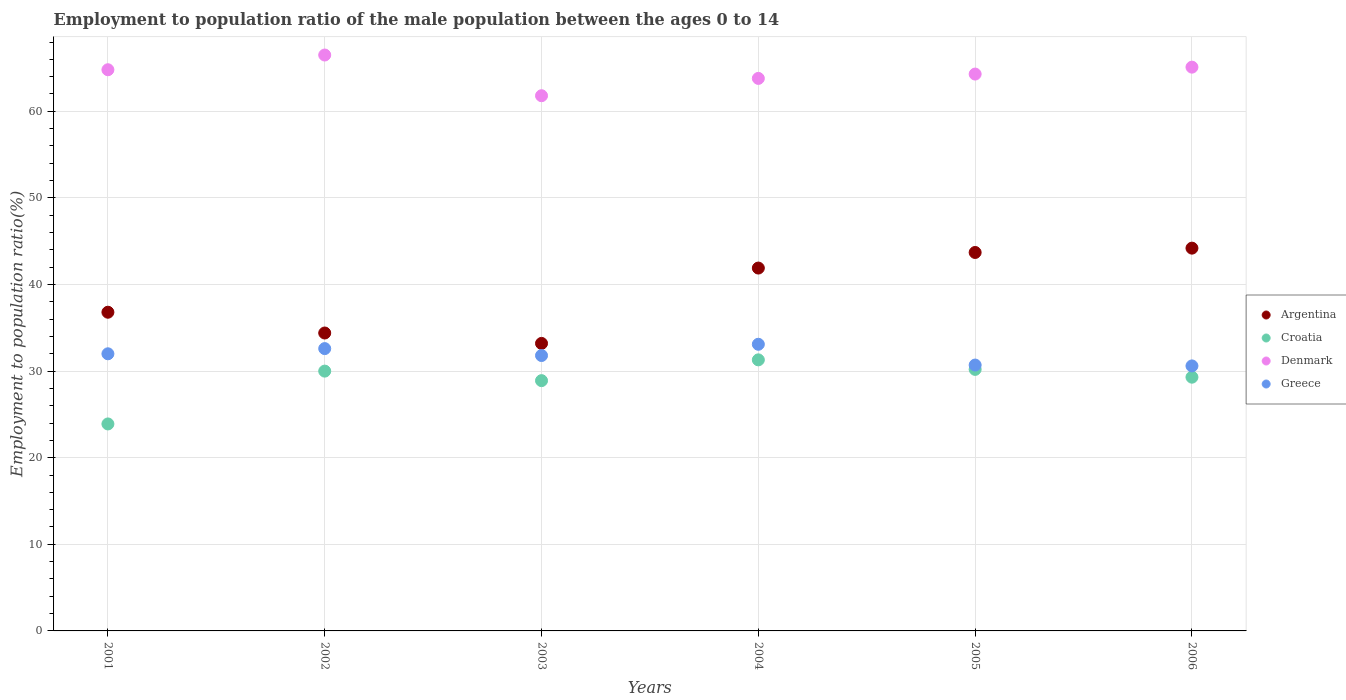What is the employment to population ratio in Greece in 2002?
Make the answer very short. 32.6. Across all years, what is the maximum employment to population ratio in Denmark?
Make the answer very short. 66.5. Across all years, what is the minimum employment to population ratio in Croatia?
Offer a terse response. 23.9. What is the total employment to population ratio in Croatia in the graph?
Offer a very short reply. 173.6. What is the difference between the employment to population ratio in Croatia in 2006 and the employment to population ratio in Denmark in 2005?
Provide a succinct answer. -35. What is the average employment to population ratio in Croatia per year?
Your response must be concise. 28.93. In the year 2003, what is the difference between the employment to population ratio in Greece and employment to population ratio in Argentina?
Your answer should be very brief. -1.4. What is the ratio of the employment to population ratio in Denmark in 2004 to that in 2005?
Your answer should be very brief. 0.99. Is the difference between the employment to population ratio in Greece in 2001 and 2006 greater than the difference between the employment to population ratio in Argentina in 2001 and 2006?
Your answer should be compact. Yes. What is the difference between the highest and the second highest employment to population ratio in Croatia?
Your answer should be very brief. 1.1. In how many years, is the employment to population ratio in Argentina greater than the average employment to population ratio in Argentina taken over all years?
Your answer should be very brief. 3. Is the sum of the employment to population ratio in Argentina in 2001 and 2006 greater than the maximum employment to population ratio in Croatia across all years?
Ensure brevity in your answer.  Yes. Is it the case that in every year, the sum of the employment to population ratio in Argentina and employment to population ratio in Greece  is greater than the sum of employment to population ratio in Croatia and employment to population ratio in Denmark?
Ensure brevity in your answer.  No. Is the employment to population ratio in Croatia strictly less than the employment to population ratio in Denmark over the years?
Provide a succinct answer. Yes. How many years are there in the graph?
Your answer should be compact. 6. Does the graph contain grids?
Your answer should be compact. Yes. Where does the legend appear in the graph?
Provide a short and direct response. Center right. What is the title of the graph?
Offer a terse response. Employment to population ratio of the male population between the ages 0 to 14. What is the Employment to population ratio(%) in Argentina in 2001?
Your answer should be very brief. 36.8. What is the Employment to population ratio(%) in Croatia in 2001?
Your answer should be compact. 23.9. What is the Employment to population ratio(%) in Denmark in 2001?
Your response must be concise. 64.8. What is the Employment to population ratio(%) of Greece in 2001?
Your answer should be compact. 32. What is the Employment to population ratio(%) in Argentina in 2002?
Offer a terse response. 34.4. What is the Employment to population ratio(%) in Denmark in 2002?
Ensure brevity in your answer.  66.5. What is the Employment to population ratio(%) in Greece in 2002?
Give a very brief answer. 32.6. What is the Employment to population ratio(%) in Argentina in 2003?
Provide a short and direct response. 33.2. What is the Employment to population ratio(%) in Croatia in 2003?
Your answer should be very brief. 28.9. What is the Employment to population ratio(%) in Denmark in 2003?
Provide a succinct answer. 61.8. What is the Employment to population ratio(%) of Greece in 2003?
Make the answer very short. 31.8. What is the Employment to population ratio(%) of Argentina in 2004?
Your answer should be compact. 41.9. What is the Employment to population ratio(%) in Croatia in 2004?
Your answer should be compact. 31.3. What is the Employment to population ratio(%) in Denmark in 2004?
Provide a succinct answer. 63.8. What is the Employment to population ratio(%) in Greece in 2004?
Your response must be concise. 33.1. What is the Employment to population ratio(%) in Argentina in 2005?
Keep it short and to the point. 43.7. What is the Employment to population ratio(%) in Croatia in 2005?
Provide a short and direct response. 30.2. What is the Employment to population ratio(%) of Denmark in 2005?
Ensure brevity in your answer.  64.3. What is the Employment to population ratio(%) in Greece in 2005?
Make the answer very short. 30.7. What is the Employment to population ratio(%) of Argentina in 2006?
Offer a terse response. 44.2. What is the Employment to population ratio(%) in Croatia in 2006?
Your answer should be compact. 29.3. What is the Employment to population ratio(%) of Denmark in 2006?
Offer a terse response. 65.1. What is the Employment to population ratio(%) in Greece in 2006?
Your answer should be compact. 30.6. Across all years, what is the maximum Employment to population ratio(%) in Argentina?
Your answer should be very brief. 44.2. Across all years, what is the maximum Employment to population ratio(%) in Croatia?
Provide a succinct answer. 31.3. Across all years, what is the maximum Employment to population ratio(%) in Denmark?
Offer a very short reply. 66.5. Across all years, what is the maximum Employment to population ratio(%) in Greece?
Keep it short and to the point. 33.1. Across all years, what is the minimum Employment to population ratio(%) in Argentina?
Provide a short and direct response. 33.2. Across all years, what is the minimum Employment to population ratio(%) of Croatia?
Give a very brief answer. 23.9. Across all years, what is the minimum Employment to population ratio(%) in Denmark?
Offer a very short reply. 61.8. Across all years, what is the minimum Employment to population ratio(%) in Greece?
Provide a succinct answer. 30.6. What is the total Employment to population ratio(%) of Argentina in the graph?
Ensure brevity in your answer.  234.2. What is the total Employment to population ratio(%) in Croatia in the graph?
Provide a succinct answer. 173.6. What is the total Employment to population ratio(%) of Denmark in the graph?
Your response must be concise. 386.3. What is the total Employment to population ratio(%) of Greece in the graph?
Your answer should be very brief. 190.8. What is the difference between the Employment to population ratio(%) in Croatia in 2001 and that in 2002?
Give a very brief answer. -6.1. What is the difference between the Employment to population ratio(%) of Denmark in 2001 and that in 2002?
Ensure brevity in your answer.  -1.7. What is the difference between the Employment to population ratio(%) of Greece in 2001 and that in 2002?
Your response must be concise. -0.6. What is the difference between the Employment to population ratio(%) of Argentina in 2001 and that in 2003?
Ensure brevity in your answer.  3.6. What is the difference between the Employment to population ratio(%) of Croatia in 2001 and that in 2003?
Ensure brevity in your answer.  -5. What is the difference between the Employment to population ratio(%) of Denmark in 2001 and that in 2003?
Your answer should be compact. 3. What is the difference between the Employment to population ratio(%) of Greece in 2001 and that in 2003?
Your answer should be compact. 0.2. What is the difference between the Employment to population ratio(%) in Argentina in 2001 and that in 2004?
Ensure brevity in your answer.  -5.1. What is the difference between the Employment to population ratio(%) in Croatia in 2001 and that in 2004?
Keep it short and to the point. -7.4. What is the difference between the Employment to population ratio(%) of Greece in 2001 and that in 2004?
Your response must be concise. -1.1. What is the difference between the Employment to population ratio(%) of Argentina in 2001 and that in 2005?
Provide a succinct answer. -6.9. What is the difference between the Employment to population ratio(%) of Greece in 2001 and that in 2005?
Make the answer very short. 1.3. What is the difference between the Employment to population ratio(%) of Denmark in 2001 and that in 2006?
Offer a very short reply. -0.3. What is the difference between the Employment to population ratio(%) in Greece in 2001 and that in 2006?
Provide a short and direct response. 1.4. What is the difference between the Employment to population ratio(%) of Croatia in 2002 and that in 2003?
Offer a very short reply. 1.1. What is the difference between the Employment to population ratio(%) in Greece in 2002 and that in 2003?
Provide a short and direct response. 0.8. What is the difference between the Employment to population ratio(%) of Greece in 2002 and that in 2004?
Make the answer very short. -0.5. What is the difference between the Employment to population ratio(%) of Denmark in 2002 and that in 2005?
Your answer should be very brief. 2.2. What is the difference between the Employment to population ratio(%) in Greece in 2002 and that in 2005?
Offer a very short reply. 1.9. What is the difference between the Employment to population ratio(%) of Croatia in 2002 and that in 2006?
Your answer should be compact. 0.7. What is the difference between the Employment to population ratio(%) of Croatia in 2003 and that in 2004?
Keep it short and to the point. -2.4. What is the difference between the Employment to population ratio(%) in Denmark in 2003 and that in 2004?
Offer a very short reply. -2. What is the difference between the Employment to population ratio(%) in Greece in 2003 and that in 2004?
Your answer should be compact. -1.3. What is the difference between the Employment to population ratio(%) of Argentina in 2003 and that in 2005?
Keep it short and to the point. -10.5. What is the difference between the Employment to population ratio(%) of Argentina in 2003 and that in 2006?
Keep it short and to the point. -11. What is the difference between the Employment to population ratio(%) of Croatia in 2003 and that in 2006?
Offer a very short reply. -0.4. What is the difference between the Employment to population ratio(%) in Denmark in 2003 and that in 2006?
Make the answer very short. -3.3. What is the difference between the Employment to population ratio(%) of Greece in 2003 and that in 2006?
Your answer should be compact. 1.2. What is the difference between the Employment to population ratio(%) in Argentina in 2004 and that in 2005?
Provide a short and direct response. -1.8. What is the difference between the Employment to population ratio(%) in Croatia in 2004 and that in 2005?
Offer a terse response. 1.1. What is the difference between the Employment to population ratio(%) in Greece in 2004 and that in 2005?
Keep it short and to the point. 2.4. What is the difference between the Employment to population ratio(%) in Croatia in 2004 and that in 2006?
Give a very brief answer. 2. What is the difference between the Employment to population ratio(%) in Denmark in 2004 and that in 2006?
Your answer should be very brief. -1.3. What is the difference between the Employment to population ratio(%) of Argentina in 2005 and that in 2006?
Provide a short and direct response. -0.5. What is the difference between the Employment to population ratio(%) of Argentina in 2001 and the Employment to population ratio(%) of Croatia in 2002?
Provide a succinct answer. 6.8. What is the difference between the Employment to population ratio(%) in Argentina in 2001 and the Employment to population ratio(%) in Denmark in 2002?
Your answer should be compact. -29.7. What is the difference between the Employment to population ratio(%) of Argentina in 2001 and the Employment to population ratio(%) of Greece in 2002?
Make the answer very short. 4.2. What is the difference between the Employment to population ratio(%) of Croatia in 2001 and the Employment to population ratio(%) of Denmark in 2002?
Your answer should be very brief. -42.6. What is the difference between the Employment to population ratio(%) in Croatia in 2001 and the Employment to population ratio(%) in Greece in 2002?
Keep it short and to the point. -8.7. What is the difference between the Employment to population ratio(%) of Denmark in 2001 and the Employment to population ratio(%) of Greece in 2002?
Give a very brief answer. 32.2. What is the difference between the Employment to population ratio(%) of Argentina in 2001 and the Employment to population ratio(%) of Croatia in 2003?
Offer a very short reply. 7.9. What is the difference between the Employment to population ratio(%) of Argentina in 2001 and the Employment to population ratio(%) of Denmark in 2003?
Your answer should be compact. -25. What is the difference between the Employment to population ratio(%) of Croatia in 2001 and the Employment to population ratio(%) of Denmark in 2003?
Offer a very short reply. -37.9. What is the difference between the Employment to population ratio(%) in Argentina in 2001 and the Employment to population ratio(%) in Greece in 2004?
Keep it short and to the point. 3.7. What is the difference between the Employment to population ratio(%) of Croatia in 2001 and the Employment to population ratio(%) of Denmark in 2004?
Provide a short and direct response. -39.9. What is the difference between the Employment to population ratio(%) of Denmark in 2001 and the Employment to population ratio(%) of Greece in 2004?
Your answer should be compact. 31.7. What is the difference between the Employment to population ratio(%) of Argentina in 2001 and the Employment to population ratio(%) of Croatia in 2005?
Provide a succinct answer. 6.6. What is the difference between the Employment to population ratio(%) of Argentina in 2001 and the Employment to population ratio(%) of Denmark in 2005?
Your answer should be very brief. -27.5. What is the difference between the Employment to population ratio(%) of Argentina in 2001 and the Employment to population ratio(%) of Greece in 2005?
Ensure brevity in your answer.  6.1. What is the difference between the Employment to population ratio(%) in Croatia in 2001 and the Employment to population ratio(%) in Denmark in 2005?
Make the answer very short. -40.4. What is the difference between the Employment to population ratio(%) of Croatia in 2001 and the Employment to population ratio(%) of Greece in 2005?
Make the answer very short. -6.8. What is the difference between the Employment to population ratio(%) in Denmark in 2001 and the Employment to population ratio(%) in Greece in 2005?
Offer a terse response. 34.1. What is the difference between the Employment to population ratio(%) of Argentina in 2001 and the Employment to population ratio(%) of Denmark in 2006?
Provide a short and direct response. -28.3. What is the difference between the Employment to population ratio(%) of Argentina in 2001 and the Employment to population ratio(%) of Greece in 2006?
Provide a short and direct response. 6.2. What is the difference between the Employment to population ratio(%) in Croatia in 2001 and the Employment to population ratio(%) in Denmark in 2006?
Your answer should be compact. -41.2. What is the difference between the Employment to population ratio(%) of Denmark in 2001 and the Employment to population ratio(%) of Greece in 2006?
Give a very brief answer. 34.2. What is the difference between the Employment to population ratio(%) in Argentina in 2002 and the Employment to population ratio(%) in Croatia in 2003?
Your response must be concise. 5.5. What is the difference between the Employment to population ratio(%) of Argentina in 2002 and the Employment to population ratio(%) of Denmark in 2003?
Offer a very short reply. -27.4. What is the difference between the Employment to population ratio(%) in Croatia in 2002 and the Employment to population ratio(%) in Denmark in 2003?
Make the answer very short. -31.8. What is the difference between the Employment to population ratio(%) of Croatia in 2002 and the Employment to population ratio(%) of Greece in 2003?
Your response must be concise. -1.8. What is the difference between the Employment to population ratio(%) of Denmark in 2002 and the Employment to population ratio(%) of Greece in 2003?
Keep it short and to the point. 34.7. What is the difference between the Employment to population ratio(%) in Argentina in 2002 and the Employment to population ratio(%) in Croatia in 2004?
Ensure brevity in your answer.  3.1. What is the difference between the Employment to population ratio(%) of Argentina in 2002 and the Employment to population ratio(%) of Denmark in 2004?
Offer a terse response. -29.4. What is the difference between the Employment to population ratio(%) of Argentina in 2002 and the Employment to population ratio(%) of Greece in 2004?
Ensure brevity in your answer.  1.3. What is the difference between the Employment to population ratio(%) in Croatia in 2002 and the Employment to population ratio(%) in Denmark in 2004?
Give a very brief answer. -33.8. What is the difference between the Employment to population ratio(%) in Denmark in 2002 and the Employment to population ratio(%) in Greece in 2004?
Offer a very short reply. 33.4. What is the difference between the Employment to population ratio(%) in Argentina in 2002 and the Employment to population ratio(%) in Croatia in 2005?
Ensure brevity in your answer.  4.2. What is the difference between the Employment to population ratio(%) of Argentina in 2002 and the Employment to population ratio(%) of Denmark in 2005?
Offer a very short reply. -29.9. What is the difference between the Employment to population ratio(%) of Croatia in 2002 and the Employment to population ratio(%) of Denmark in 2005?
Provide a succinct answer. -34.3. What is the difference between the Employment to population ratio(%) of Denmark in 2002 and the Employment to population ratio(%) of Greece in 2005?
Ensure brevity in your answer.  35.8. What is the difference between the Employment to population ratio(%) of Argentina in 2002 and the Employment to population ratio(%) of Denmark in 2006?
Your answer should be compact. -30.7. What is the difference between the Employment to population ratio(%) in Croatia in 2002 and the Employment to population ratio(%) in Denmark in 2006?
Offer a terse response. -35.1. What is the difference between the Employment to population ratio(%) of Croatia in 2002 and the Employment to population ratio(%) of Greece in 2006?
Provide a short and direct response. -0.6. What is the difference between the Employment to population ratio(%) in Denmark in 2002 and the Employment to population ratio(%) in Greece in 2006?
Ensure brevity in your answer.  35.9. What is the difference between the Employment to population ratio(%) in Argentina in 2003 and the Employment to population ratio(%) in Denmark in 2004?
Give a very brief answer. -30.6. What is the difference between the Employment to population ratio(%) of Croatia in 2003 and the Employment to population ratio(%) of Denmark in 2004?
Your response must be concise. -34.9. What is the difference between the Employment to population ratio(%) in Croatia in 2003 and the Employment to population ratio(%) in Greece in 2004?
Keep it short and to the point. -4.2. What is the difference between the Employment to population ratio(%) of Denmark in 2003 and the Employment to population ratio(%) of Greece in 2004?
Ensure brevity in your answer.  28.7. What is the difference between the Employment to population ratio(%) of Argentina in 2003 and the Employment to population ratio(%) of Denmark in 2005?
Keep it short and to the point. -31.1. What is the difference between the Employment to population ratio(%) of Argentina in 2003 and the Employment to population ratio(%) of Greece in 2005?
Make the answer very short. 2.5. What is the difference between the Employment to population ratio(%) of Croatia in 2003 and the Employment to population ratio(%) of Denmark in 2005?
Offer a very short reply. -35.4. What is the difference between the Employment to population ratio(%) in Croatia in 2003 and the Employment to population ratio(%) in Greece in 2005?
Your answer should be very brief. -1.8. What is the difference between the Employment to population ratio(%) of Denmark in 2003 and the Employment to population ratio(%) of Greece in 2005?
Your response must be concise. 31.1. What is the difference between the Employment to population ratio(%) in Argentina in 2003 and the Employment to population ratio(%) in Denmark in 2006?
Offer a terse response. -31.9. What is the difference between the Employment to population ratio(%) of Argentina in 2003 and the Employment to population ratio(%) of Greece in 2006?
Provide a succinct answer. 2.6. What is the difference between the Employment to population ratio(%) of Croatia in 2003 and the Employment to population ratio(%) of Denmark in 2006?
Ensure brevity in your answer.  -36.2. What is the difference between the Employment to population ratio(%) in Denmark in 2003 and the Employment to population ratio(%) in Greece in 2006?
Your answer should be compact. 31.2. What is the difference between the Employment to population ratio(%) of Argentina in 2004 and the Employment to population ratio(%) of Croatia in 2005?
Make the answer very short. 11.7. What is the difference between the Employment to population ratio(%) in Argentina in 2004 and the Employment to population ratio(%) in Denmark in 2005?
Your response must be concise. -22.4. What is the difference between the Employment to population ratio(%) in Croatia in 2004 and the Employment to population ratio(%) in Denmark in 2005?
Give a very brief answer. -33. What is the difference between the Employment to population ratio(%) of Denmark in 2004 and the Employment to population ratio(%) of Greece in 2005?
Your answer should be compact. 33.1. What is the difference between the Employment to population ratio(%) of Argentina in 2004 and the Employment to population ratio(%) of Denmark in 2006?
Offer a terse response. -23.2. What is the difference between the Employment to population ratio(%) in Croatia in 2004 and the Employment to population ratio(%) in Denmark in 2006?
Give a very brief answer. -33.8. What is the difference between the Employment to population ratio(%) in Denmark in 2004 and the Employment to population ratio(%) in Greece in 2006?
Offer a terse response. 33.2. What is the difference between the Employment to population ratio(%) of Argentina in 2005 and the Employment to population ratio(%) of Denmark in 2006?
Keep it short and to the point. -21.4. What is the difference between the Employment to population ratio(%) of Croatia in 2005 and the Employment to population ratio(%) of Denmark in 2006?
Provide a short and direct response. -34.9. What is the difference between the Employment to population ratio(%) in Denmark in 2005 and the Employment to population ratio(%) in Greece in 2006?
Keep it short and to the point. 33.7. What is the average Employment to population ratio(%) of Argentina per year?
Your answer should be very brief. 39.03. What is the average Employment to population ratio(%) of Croatia per year?
Keep it short and to the point. 28.93. What is the average Employment to population ratio(%) in Denmark per year?
Your answer should be compact. 64.38. What is the average Employment to population ratio(%) in Greece per year?
Make the answer very short. 31.8. In the year 2001, what is the difference between the Employment to population ratio(%) of Argentina and Employment to population ratio(%) of Denmark?
Keep it short and to the point. -28. In the year 2001, what is the difference between the Employment to population ratio(%) in Argentina and Employment to population ratio(%) in Greece?
Offer a terse response. 4.8. In the year 2001, what is the difference between the Employment to population ratio(%) of Croatia and Employment to population ratio(%) of Denmark?
Offer a very short reply. -40.9. In the year 2001, what is the difference between the Employment to population ratio(%) of Denmark and Employment to population ratio(%) of Greece?
Offer a terse response. 32.8. In the year 2002, what is the difference between the Employment to population ratio(%) in Argentina and Employment to population ratio(%) in Croatia?
Offer a very short reply. 4.4. In the year 2002, what is the difference between the Employment to population ratio(%) of Argentina and Employment to population ratio(%) of Denmark?
Give a very brief answer. -32.1. In the year 2002, what is the difference between the Employment to population ratio(%) of Argentina and Employment to population ratio(%) of Greece?
Give a very brief answer. 1.8. In the year 2002, what is the difference between the Employment to population ratio(%) of Croatia and Employment to population ratio(%) of Denmark?
Ensure brevity in your answer.  -36.5. In the year 2002, what is the difference between the Employment to population ratio(%) of Denmark and Employment to population ratio(%) of Greece?
Offer a very short reply. 33.9. In the year 2003, what is the difference between the Employment to population ratio(%) in Argentina and Employment to population ratio(%) in Denmark?
Give a very brief answer. -28.6. In the year 2003, what is the difference between the Employment to population ratio(%) in Argentina and Employment to population ratio(%) in Greece?
Your answer should be compact. 1.4. In the year 2003, what is the difference between the Employment to population ratio(%) in Croatia and Employment to population ratio(%) in Denmark?
Offer a terse response. -32.9. In the year 2003, what is the difference between the Employment to population ratio(%) of Croatia and Employment to population ratio(%) of Greece?
Provide a succinct answer. -2.9. In the year 2004, what is the difference between the Employment to population ratio(%) in Argentina and Employment to population ratio(%) in Denmark?
Provide a short and direct response. -21.9. In the year 2004, what is the difference between the Employment to population ratio(%) of Croatia and Employment to population ratio(%) of Denmark?
Make the answer very short. -32.5. In the year 2004, what is the difference between the Employment to population ratio(%) in Denmark and Employment to population ratio(%) in Greece?
Offer a terse response. 30.7. In the year 2005, what is the difference between the Employment to population ratio(%) in Argentina and Employment to population ratio(%) in Croatia?
Provide a succinct answer. 13.5. In the year 2005, what is the difference between the Employment to population ratio(%) of Argentina and Employment to population ratio(%) of Denmark?
Provide a succinct answer. -20.6. In the year 2005, what is the difference between the Employment to population ratio(%) of Croatia and Employment to population ratio(%) of Denmark?
Offer a very short reply. -34.1. In the year 2005, what is the difference between the Employment to population ratio(%) of Croatia and Employment to population ratio(%) of Greece?
Your answer should be compact. -0.5. In the year 2005, what is the difference between the Employment to population ratio(%) of Denmark and Employment to population ratio(%) of Greece?
Provide a succinct answer. 33.6. In the year 2006, what is the difference between the Employment to population ratio(%) of Argentina and Employment to population ratio(%) of Croatia?
Ensure brevity in your answer.  14.9. In the year 2006, what is the difference between the Employment to population ratio(%) in Argentina and Employment to population ratio(%) in Denmark?
Provide a short and direct response. -20.9. In the year 2006, what is the difference between the Employment to population ratio(%) of Croatia and Employment to population ratio(%) of Denmark?
Give a very brief answer. -35.8. In the year 2006, what is the difference between the Employment to population ratio(%) in Denmark and Employment to population ratio(%) in Greece?
Ensure brevity in your answer.  34.5. What is the ratio of the Employment to population ratio(%) in Argentina in 2001 to that in 2002?
Keep it short and to the point. 1.07. What is the ratio of the Employment to population ratio(%) of Croatia in 2001 to that in 2002?
Provide a succinct answer. 0.8. What is the ratio of the Employment to population ratio(%) in Denmark in 2001 to that in 2002?
Provide a short and direct response. 0.97. What is the ratio of the Employment to population ratio(%) in Greece in 2001 to that in 2002?
Your answer should be very brief. 0.98. What is the ratio of the Employment to population ratio(%) of Argentina in 2001 to that in 2003?
Your answer should be compact. 1.11. What is the ratio of the Employment to population ratio(%) in Croatia in 2001 to that in 2003?
Your answer should be very brief. 0.83. What is the ratio of the Employment to population ratio(%) of Denmark in 2001 to that in 2003?
Give a very brief answer. 1.05. What is the ratio of the Employment to population ratio(%) of Argentina in 2001 to that in 2004?
Provide a succinct answer. 0.88. What is the ratio of the Employment to population ratio(%) of Croatia in 2001 to that in 2004?
Make the answer very short. 0.76. What is the ratio of the Employment to population ratio(%) in Denmark in 2001 to that in 2004?
Provide a short and direct response. 1.02. What is the ratio of the Employment to population ratio(%) of Greece in 2001 to that in 2004?
Your answer should be compact. 0.97. What is the ratio of the Employment to population ratio(%) of Argentina in 2001 to that in 2005?
Give a very brief answer. 0.84. What is the ratio of the Employment to population ratio(%) in Croatia in 2001 to that in 2005?
Keep it short and to the point. 0.79. What is the ratio of the Employment to population ratio(%) in Denmark in 2001 to that in 2005?
Keep it short and to the point. 1.01. What is the ratio of the Employment to population ratio(%) of Greece in 2001 to that in 2005?
Give a very brief answer. 1.04. What is the ratio of the Employment to population ratio(%) of Argentina in 2001 to that in 2006?
Offer a terse response. 0.83. What is the ratio of the Employment to population ratio(%) in Croatia in 2001 to that in 2006?
Keep it short and to the point. 0.82. What is the ratio of the Employment to population ratio(%) of Greece in 2001 to that in 2006?
Make the answer very short. 1.05. What is the ratio of the Employment to population ratio(%) of Argentina in 2002 to that in 2003?
Offer a terse response. 1.04. What is the ratio of the Employment to population ratio(%) of Croatia in 2002 to that in 2003?
Your response must be concise. 1.04. What is the ratio of the Employment to population ratio(%) in Denmark in 2002 to that in 2003?
Give a very brief answer. 1.08. What is the ratio of the Employment to population ratio(%) in Greece in 2002 to that in 2003?
Make the answer very short. 1.03. What is the ratio of the Employment to population ratio(%) in Argentina in 2002 to that in 2004?
Keep it short and to the point. 0.82. What is the ratio of the Employment to population ratio(%) of Croatia in 2002 to that in 2004?
Ensure brevity in your answer.  0.96. What is the ratio of the Employment to population ratio(%) of Denmark in 2002 to that in 2004?
Give a very brief answer. 1.04. What is the ratio of the Employment to population ratio(%) in Greece in 2002 to that in 2004?
Provide a short and direct response. 0.98. What is the ratio of the Employment to population ratio(%) in Argentina in 2002 to that in 2005?
Your response must be concise. 0.79. What is the ratio of the Employment to population ratio(%) in Denmark in 2002 to that in 2005?
Keep it short and to the point. 1.03. What is the ratio of the Employment to population ratio(%) in Greece in 2002 to that in 2005?
Offer a very short reply. 1.06. What is the ratio of the Employment to population ratio(%) of Argentina in 2002 to that in 2006?
Your response must be concise. 0.78. What is the ratio of the Employment to population ratio(%) in Croatia in 2002 to that in 2006?
Your answer should be compact. 1.02. What is the ratio of the Employment to population ratio(%) of Denmark in 2002 to that in 2006?
Your answer should be compact. 1.02. What is the ratio of the Employment to population ratio(%) of Greece in 2002 to that in 2006?
Offer a very short reply. 1.07. What is the ratio of the Employment to population ratio(%) in Argentina in 2003 to that in 2004?
Ensure brevity in your answer.  0.79. What is the ratio of the Employment to population ratio(%) of Croatia in 2003 to that in 2004?
Provide a succinct answer. 0.92. What is the ratio of the Employment to population ratio(%) in Denmark in 2003 to that in 2004?
Your answer should be compact. 0.97. What is the ratio of the Employment to population ratio(%) of Greece in 2003 to that in 2004?
Ensure brevity in your answer.  0.96. What is the ratio of the Employment to population ratio(%) of Argentina in 2003 to that in 2005?
Provide a short and direct response. 0.76. What is the ratio of the Employment to population ratio(%) in Denmark in 2003 to that in 2005?
Provide a succinct answer. 0.96. What is the ratio of the Employment to population ratio(%) in Greece in 2003 to that in 2005?
Make the answer very short. 1.04. What is the ratio of the Employment to population ratio(%) of Argentina in 2003 to that in 2006?
Your response must be concise. 0.75. What is the ratio of the Employment to population ratio(%) in Croatia in 2003 to that in 2006?
Your answer should be compact. 0.99. What is the ratio of the Employment to population ratio(%) in Denmark in 2003 to that in 2006?
Ensure brevity in your answer.  0.95. What is the ratio of the Employment to population ratio(%) of Greece in 2003 to that in 2006?
Your answer should be very brief. 1.04. What is the ratio of the Employment to population ratio(%) in Argentina in 2004 to that in 2005?
Your response must be concise. 0.96. What is the ratio of the Employment to population ratio(%) in Croatia in 2004 to that in 2005?
Your answer should be compact. 1.04. What is the ratio of the Employment to population ratio(%) of Denmark in 2004 to that in 2005?
Provide a short and direct response. 0.99. What is the ratio of the Employment to population ratio(%) in Greece in 2004 to that in 2005?
Provide a short and direct response. 1.08. What is the ratio of the Employment to population ratio(%) in Argentina in 2004 to that in 2006?
Give a very brief answer. 0.95. What is the ratio of the Employment to population ratio(%) in Croatia in 2004 to that in 2006?
Provide a succinct answer. 1.07. What is the ratio of the Employment to population ratio(%) of Denmark in 2004 to that in 2006?
Provide a short and direct response. 0.98. What is the ratio of the Employment to population ratio(%) in Greece in 2004 to that in 2006?
Keep it short and to the point. 1.08. What is the ratio of the Employment to population ratio(%) of Argentina in 2005 to that in 2006?
Make the answer very short. 0.99. What is the ratio of the Employment to population ratio(%) in Croatia in 2005 to that in 2006?
Offer a very short reply. 1.03. What is the ratio of the Employment to population ratio(%) of Greece in 2005 to that in 2006?
Ensure brevity in your answer.  1. What is the difference between the highest and the second highest Employment to population ratio(%) in Argentina?
Your answer should be compact. 0.5. What is the difference between the highest and the second highest Employment to population ratio(%) of Denmark?
Provide a short and direct response. 1.4. What is the difference between the highest and the lowest Employment to population ratio(%) in Croatia?
Keep it short and to the point. 7.4. What is the difference between the highest and the lowest Employment to population ratio(%) in Denmark?
Keep it short and to the point. 4.7. 